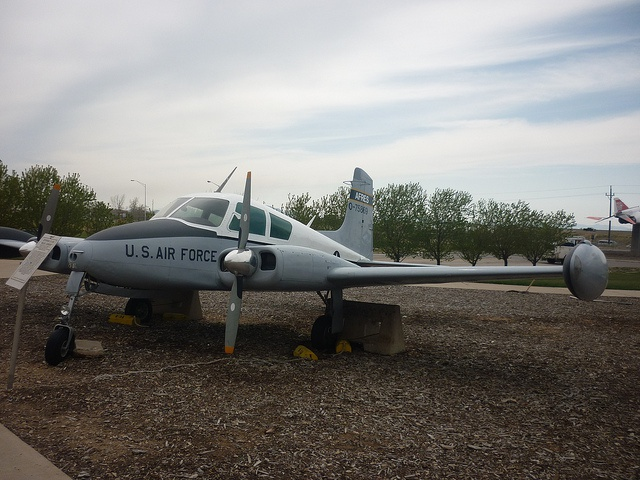Describe the objects in this image and their specific colors. I can see airplane in lightgray, gray, black, and darkgray tones and airplane in lightgray, darkgray, gray, and black tones in this image. 